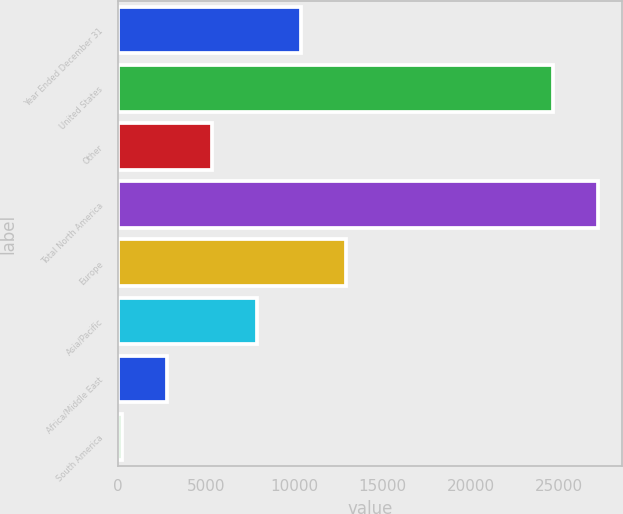Convert chart to OTSL. <chart><loc_0><loc_0><loc_500><loc_500><bar_chart><fcel>Year Ended December 31<fcel>United States<fcel>Other<fcel>Total North America<fcel>Europe<fcel>Asia/Pacific<fcel>Africa/Middle East<fcel>South America<nl><fcel>10396.8<fcel>24636<fcel>5305.4<fcel>27181.7<fcel>12942.5<fcel>7851.1<fcel>2759.7<fcel>214<nl></chart> 